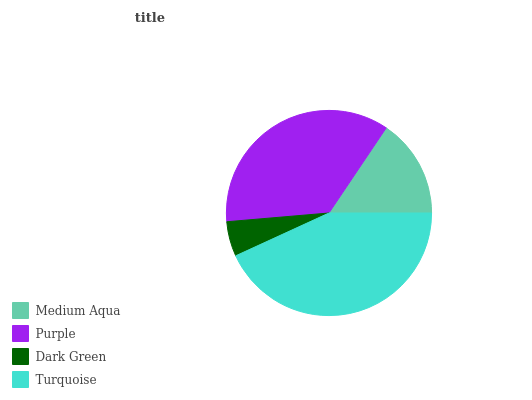Is Dark Green the minimum?
Answer yes or no. Yes. Is Turquoise the maximum?
Answer yes or no. Yes. Is Purple the minimum?
Answer yes or no. No. Is Purple the maximum?
Answer yes or no. No. Is Purple greater than Medium Aqua?
Answer yes or no. Yes. Is Medium Aqua less than Purple?
Answer yes or no. Yes. Is Medium Aqua greater than Purple?
Answer yes or no. No. Is Purple less than Medium Aqua?
Answer yes or no. No. Is Purple the high median?
Answer yes or no. Yes. Is Medium Aqua the low median?
Answer yes or no. Yes. Is Medium Aqua the high median?
Answer yes or no. No. Is Purple the low median?
Answer yes or no. No. 